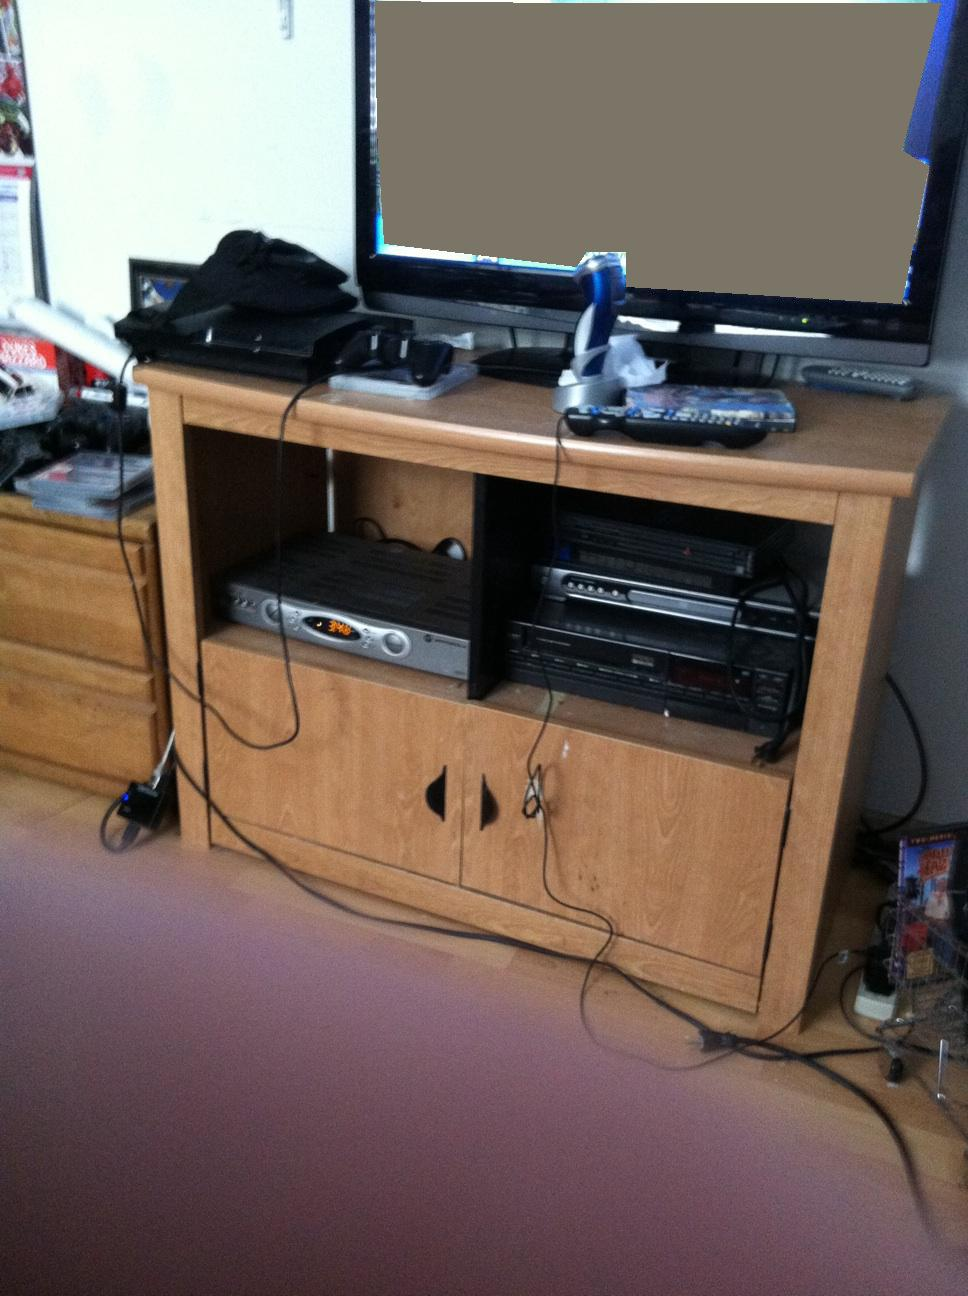What can we infer about the owner's interests from the image? The owner appears to be interested in video gaming and possibly other forms of media entertainment, such as watching movies and listening to music, given the presence of various related electronic devices and controls. What would be a thoughtful addition to this entertainment setup? Adding a high-quality speaker system could enhance the audio experience for games and movies. A cable management system could also help in organizing the visible wires for a neater appearance. 